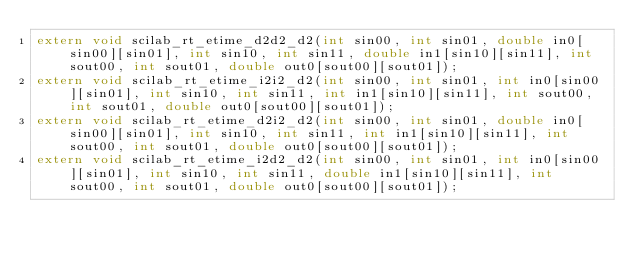<code> <loc_0><loc_0><loc_500><loc_500><_C_>extern void scilab_rt_etime_d2d2_d2(int sin00, int sin01, double in0[sin00][sin01], int sin10, int sin11, double in1[sin10][sin11], int sout00, int sout01, double out0[sout00][sout01]);
extern void scilab_rt_etime_i2i2_d2(int sin00, int sin01, int in0[sin00][sin01], int sin10, int sin11, int in1[sin10][sin11], int sout00, int sout01, double out0[sout00][sout01]);
extern void scilab_rt_etime_d2i2_d2(int sin00, int sin01, double in0[sin00][sin01], int sin10, int sin11, int in1[sin10][sin11], int sout00, int sout01, double out0[sout00][sout01]);
extern void scilab_rt_etime_i2d2_d2(int sin00, int sin01, int in0[sin00][sin01], int sin10, int sin11, double in1[sin10][sin11], int sout00, int sout01, double out0[sout00][sout01]);
</code> 